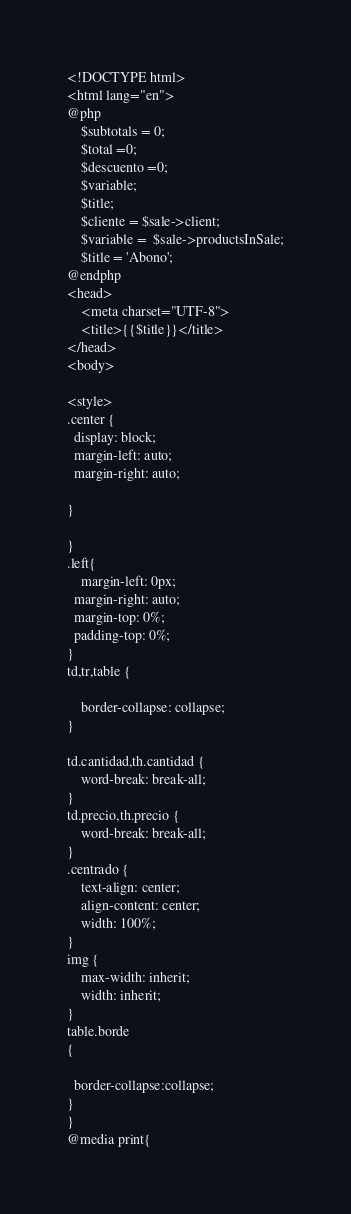Convert code to text. <code><loc_0><loc_0><loc_500><loc_500><_PHP_><!DOCTYPE html>
<html lang="en">
@php
    $subtotals = 0;
    $total =0;
    $descuento =0;
    $variable;
    $title;
    $cliente = $sale->client;
    $variable =  $sale->productsInSale;
    $title = 'Abono';
@endphp
<head>
    <meta charset="UTF-8">
    <title>{{$title}}</title>    
</head>
<body>

<style>
.center {
  display: block;
  margin-left: auto;
  margin-right: auto;
   
}

}
.left{
    margin-left: 0px;
  margin-right: auto;
  margin-top: 0%;
  padding-top: 0%;
}
td,tr,table {
   
    border-collapse: collapse;
}

td.cantidad,th.cantidad {
    word-break: break-all;
}
td.precio,th.precio {
    word-break: break-all;
}
.centrado {
    text-align: center;
    align-content: center;
    width: 100%;
}
img {
    max-width: inherit;
    width: inherit;
}
table.borde
{

  border-collapse:collapse;
}
}
@media print{</code> 